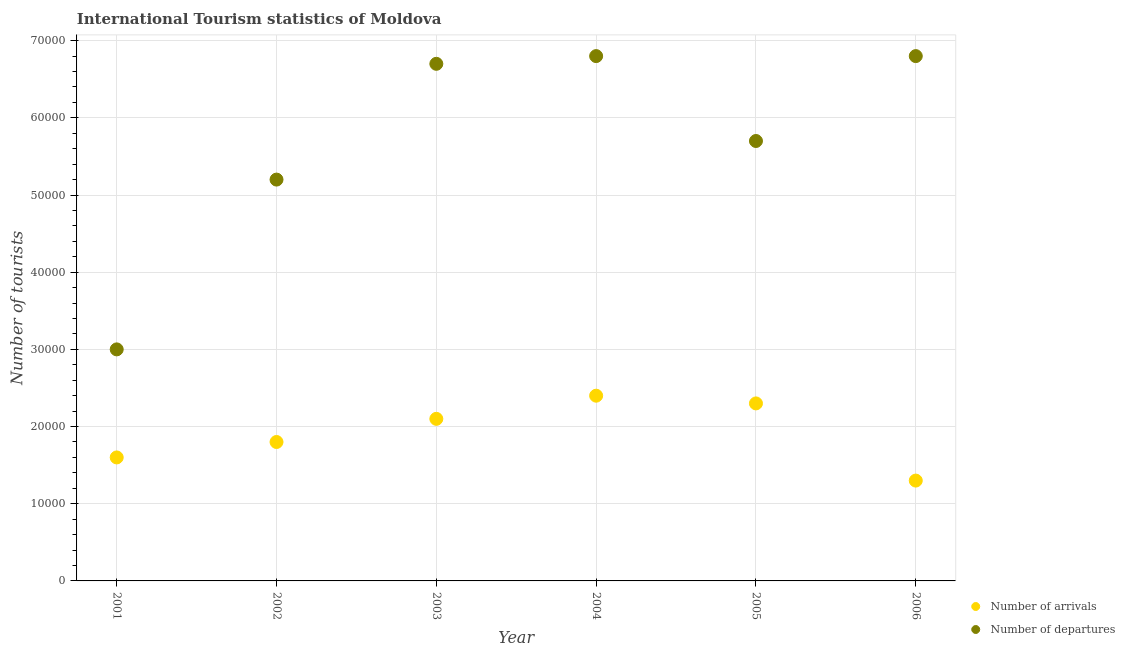What is the number of tourist departures in 2002?
Your answer should be very brief. 5.20e+04. Across all years, what is the maximum number of tourist arrivals?
Ensure brevity in your answer.  2.40e+04. Across all years, what is the minimum number of tourist departures?
Provide a short and direct response. 3.00e+04. In which year was the number of tourist departures maximum?
Provide a short and direct response. 2004. In which year was the number of tourist arrivals minimum?
Provide a short and direct response. 2006. What is the total number of tourist arrivals in the graph?
Keep it short and to the point. 1.15e+05. What is the difference between the number of tourist arrivals in 2001 and that in 2005?
Offer a very short reply. -7000. What is the difference between the number of tourist arrivals in 2002 and the number of tourist departures in 2005?
Provide a short and direct response. -3.90e+04. What is the average number of tourist departures per year?
Make the answer very short. 5.70e+04. In the year 2001, what is the difference between the number of tourist arrivals and number of tourist departures?
Your answer should be compact. -1.40e+04. What is the ratio of the number of tourist departures in 2003 to that in 2005?
Keep it short and to the point. 1.18. Is the number of tourist arrivals in 2001 less than that in 2004?
Keep it short and to the point. Yes. Is the difference between the number of tourist arrivals in 2001 and 2004 greater than the difference between the number of tourist departures in 2001 and 2004?
Make the answer very short. Yes. What is the difference between the highest and the lowest number of tourist departures?
Your answer should be very brief. 3.80e+04. In how many years, is the number of tourist departures greater than the average number of tourist departures taken over all years?
Your answer should be very brief. 3. Is the number of tourist departures strictly less than the number of tourist arrivals over the years?
Your answer should be very brief. No. How many years are there in the graph?
Provide a succinct answer. 6. Are the values on the major ticks of Y-axis written in scientific E-notation?
Make the answer very short. No. Does the graph contain grids?
Offer a very short reply. Yes. How are the legend labels stacked?
Keep it short and to the point. Vertical. What is the title of the graph?
Make the answer very short. International Tourism statistics of Moldova. Does "Male" appear as one of the legend labels in the graph?
Your answer should be compact. No. What is the label or title of the X-axis?
Keep it short and to the point. Year. What is the label or title of the Y-axis?
Your answer should be very brief. Number of tourists. What is the Number of tourists of Number of arrivals in 2001?
Make the answer very short. 1.60e+04. What is the Number of tourists of Number of arrivals in 2002?
Make the answer very short. 1.80e+04. What is the Number of tourists in Number of departures in 2002?
Your response must be concise. 5.20e+04. What is the Number of tourists of Number of arrivals in 2003?
Provide a succinct answer. 2.10e+04. What is the Number of tourists in Number of departures in 2003?
Provide a succinct answer. 6.70e+04. What is the Number of tourists in Number of arrivals in 2004?
Your answer should be compact. 2.40e+04. What is the Number of tourists of Number of departures in 2004?
Your response must be concise. 6.80e+04. What is the Number of tourists of Number of arrivals in 2005?
Your answer should be compact. 2.30e+04. What is the Number of tourists of Number of departures in 2005?
Your answer should be compact. 5.70e+04. What is the Number of tourists in Number of arrivals in 2006?
Provide a succinct answer. 1.30e+04. What is the Number of tourists in Number of departures in 2006?
Provide a succinct answer. 6.80e+04. Across all years, what is the maximum Number of tourists of Number of arrivals?
Your answer should be very brief. 2.40e+04. Across all years, what is the maximum Number of tourists of Number of departures?
Your response must be concise. 6.80e+04. Across all years, what is the minimum Number of tourists of Number of arrivals?
Give a very brief answer. 1.30e+04. Across all years, what is the minimum Number of tourists in Number of departures?
Your response must be concise. 3.00e+04. What is the total Number of tourists of Number of arrivals in the graph?
Keep it short and to the point. 1.15e+05. What is the total Number of tourists of Number of departures in the graph?
Offer a terse response. 3.42e+05. What is the difference between the Number of tourists in Number of arrivals in 2001 and that in 2002?
Give a very brief answer. -2000. What is the difference between the Number of tourists of Number of departures in 2001 and that in 2002?
Your answer should be compact. -2.20e+04. What is the difference between the Number of tourists in Number of arrivals in 2001 and that in 2003?
Your response must be concise. -5000. What is the difference between the Number of tourists in Number of departures in 2001 and that in 2003?
Offer a terse response. -3.70e+04. What is the difference between the Number of tourists of Number of arrivals in 2001 and that in 2004?
Your answer should be compact. -8000. What is the difference between the Number of tourists in Number of departures in 2001 and that in 2004?
Your answer should be compact. -3.80e+04. What is the difference between the Number of tourists of Number of arrivals in 2001 and that in 2005?
Offer a very short reply. -7000. What is the difference between the Number of tourists of Number of departures in 2001 and that in 2005?
Give a very brief answer. -2.70e+04. What is the difference between the Number of tourists in Number of arrivals in 2001 and that in 2006?
Keep it short and to the point. 3000. What is the difference between the Number of tourists of Number of departures in 2001 and that in 2006?
Your answer should be very brief. -3.80e+04. What is the difference between the Number of tourists of Number of arrivals in 2002 and that in 2003?
Your response must be concise. -3000. What is the difference between the Number of tourists of Number of departures in 2002 and that in 2003?
Your answer should be very brief. -1.50e+04. What is the difference between the Number of tourists of Number of arrivals in 2002 and that in 2004?
Ensure brevity in your answer.  -6000. What is the difference between the Number of tourists of Number of departures in 2002 and that in 2004?
Ensure brevity in your answer.  -1.60e+04. What is the difference between the Number of tourists of Number of arrivals in 2002 and that in 2005?
Offer a very short reply. -5000. What is the difference between the Number of tourists of Number of departures in 2002 and that in 2005?
Make the answer very short. -5000. What is the difference between the Number of tourists of Number of departures in 2002 and that in 2006?
Your answer should be compact. -1.60e+04. What is the difference between the Number of tourists in Number of arrivals in 2003 and that in 2004?
Offer a terse response. -3000. What is the difference between the Number of tourists of Number of departures in 2003 and that in 2004?
Ensure brevity in your answer.  -1000. What is the difference between the Number of tourists of Number of arrivals in 2003 and that in 2005?
Offer a terse response. -2000. What is the difference between the Number of tourists of Number of departures in 2003 and that in 2005?
Your response must be concise. 10000. What is the difference between the Number of tourists in Number of arrivals in 2003 and that in 2006?
Your response must be concise. 8000. What is the difference between the Number of tourists in Number of departures in 2003 and that in 2006?
Your answer should be very brief. -1000. What is the difference between the Number of tourists in Number of arrivals in 2004 and that in 2005?
Provide a short and direct response. 1000. What is the difference between the Number of tourists in Number of departures in 2004 and that in 2005?
Offer a very short reply. 1.10e+04. What is the difference between the Number of tourists in Number of arrivals in 2004 and that in 2006?
Your response must be concise. 1.10e+04. What is the difference between the Number of tourists in Number of departures in 2004 and that in 2006?
Give a very brief answer. 0. What is the difference between the Number of tourists of Number of departures in 2005 and that in 2006?
Offer a terse response. -1.10e+04. What is the difference between the Number of tourists in Number of arrivals in 2001 and the Number of tourists in Number of departures in 2002?
Your response must be concise. -3.60e+04. What is the difference between the Number of tourists of Number of arrivals in 2001 and the Number of tourists of Number of departures in 2003?
Your answer should be compact. -5.10e+04. What is the difference between the Number of tourists in Number of arrivals in 2001 and the Number of tourists in Number of departures in 2004?
Your answer should be compact. -5.20e+04. What is the difference between the Number of tourists in Number of arrivals in 2001 and the Number of tourists in Number of departures in 2005?
Your answer should be compact. -4.10e+04. What is the difference between the Number of tourists of Number of arrivals in 2001 and the Number of tourists of Number of departures in 2006?
Your answer should be compact. -5.20e+04. What is the difference between the Number of tourists of Number of arrivals in 2002 and the Number of tourists of Number of departures in 2003?
Provide a short and direct response. -4.90e+04. What is the difference between the Number of tourists in Number of arrivals in 2002 and the Number of tourists in Number of departures in 2004?
Your answer should be compact. -5.00e+04. What is the difference between the Number of tourists in Number of arrivals in 2002 and the Number of tourists in Number of departures in 2005?
Your answer should be very brief. -3.90e+04. What is the difference between the Number of tourists in Number of arrivals in 2003 and the Number of tourists in Number of departures in 2004?
Provide a short and direct response. -4.70e+04. What is the difference between the Number of tourists of Number of arrivals in 2003 and the Number of tourists of Number of departures in 2005?
Your response must be concise. -3.60e+04. What is the difference between the Number of tourists of Number of arrivals in 2003 and the Number of tourists of Number of departures in 2006?
Provide a short and direct response. -4.70e+04. What is the difference between the Number of tourists of Number of arrivals in 2004 and the Number of tourists of Number of departures in 2005?
Your answer should be compact. -3.30e+04. What is the difference between the Number of tourists in Number of arrivals in 2004 and the Number of tourists in Number of departures in 2006?
Ensure brevity in your answer.  -4.40e+04. What is the difference between the Number of tourists of Number of arrivals in 2005 and the Number of tourists of Number of departures in 2006?
Provide a succinct answer. -4.50e+04. What is the average Number of tourists of Number of arrivals per year?
Your response must be concise. 1.92e+04. What is the average Number of tourists of Number of departures per year?
Your response must be concise. 5.70e+04. In the year 2001, what is the difference between the Number of tourists of Number of arrivals and Number of tourists of Number of departures?
Provide a succinct answer. -1.40e+04. In the year 2002, what is the difference between the Number of tourists of Number of arrivals and Number of tourists of Number of departures?
Offer a very short reply. -3.40e+04. In the year 2003, what is the difference between the Number of tourists of Number of arrivals and Number of tourists of Number of departures?
Your answer should be compact. -4.60e+04. In the year 2004, what is the difference between the Number of tourists of Number of arrivals and Number of tourists of Number of departures?
Give a very brief answer. -4.40e+04. In the year 2005, what is the difference between the Number of tourists in Number of arrivals and Number of tourists in Number of departures?
Offer a very short reply. -3.40e+04. In the year 2006, what is the difference between the Number of tourists in Number of arrivals and Number of tourists in Number of departures?
Your answer should be very brief. -5.50e+04. What is the ratio of the Number of tourists of Number of departures in 2001 to that in 2002?
Keep it short and to the point. 0.58. What is the ratio of the Number of tourists in Number of arrivals in 2001 to that in 2003?
Provide a short and direct response. 0.76. What is the ratio of the Number of tourists in Number of departures in 2001 to that in 2003?
Your response must be concise. 0.45. What is the ratio of the Number of tourists in Number of departures in 2001 to that in 2004?
Provide a succinct answer. 0.44. What is the ratio of the Number of tourists in Number of arrivals in 2001 to that in 2005?
Ensure brevity in your answer.  0.7. What is the ratio of the Number of tourists of Number of departures in 2001 to that in 2005?
Make the answer very short. 0.53. What is the ratio of the Number of tourists in Number of arrivals in 2001 to that in 2006?
Provide a succinct answer. 1.23. What is the ratio of the Number of tourists in Number of departures in 2001 to that in 2006?
Your response must be concise. 0.44. What is the ratio of the Number of tourists of Number of departures in 2002 to that in 2003?
Give a very brief answer. 0.78. What is the ratio of the Number of tourists of Number of arrivals in 2002 to that in 2004?
Provide a succinct answer. 0.75. What is the ratio of the Number of tourists in Number of departures in 2002 to that in 2004?
Your answer should be very brief. 0.76. What is the ratio of the Number of tourists of Number of arrivals in 2002 to that in 2005?
Offer a terse response. 0.78. What is the ratio of the Number of tourists in Number of departures in 2002 to that in 2005?
Your answer should be compact. 0.91. What is the ratio of the Number of tourists of Number of arrivals in 2002 to that in 2006?
Your response must be concise. 1.38. What is the ratio of the Number of tourists in Number of departures in 2002 to that in 2006?
Make the answer very short. 0.76. What is the ratio of the Number of tourists in Number of arrivals in 2003 to that in 2004?
Provide a short and direct response. 0.88. What is the ratio of the Number of tourists of Number of departures in 2003 to that in 2004?
Keep it short and to the point. 0.99. What is the ratio of the Number of tourists in Number of departures in 2003 to that in 2005?
Keep it short and to the point. 1.18. What is the ratio of the Number of tourists of Number of arrivals in 2003 to that in 2006?
Offer a terse response. 1.62. What is the ratio of the Number of tourists in Number of arrivals in 2004 to that in 2005?
Your answer should be very brief. 1.04. What is the ratio of the Number of tourists of Number of departures in 2004 to that in 2005?
Provide a succinct answer. 1.19. What is the ratio of the Number of tourists in Number of arrivals in 2004 to that in 2006?
Provide a short and direct response. 1.85. What is the ratio of the Number of tourists of Number of arrivals in 2005 to that in 2006?
Give a very brief answer. 1.77. What is the ratio of the Number of tourists in Number of departures in 2005 to that in 2006?
Provide a succinct answer. 0.84. What is the difference between the highest and the second highest Number of tourists in Number of arrivals?
Give a very brief answer. 1000. What is the difference between the highest and the second highest Number of tourists of Number of departures?
Your answer should be very brief. 0. What is the difference between the highest and the lowest Number of tourists of Number of arrivals?
Your answer should be compact. 1.10e+04. What is the difference between the highest and the lowest Number of tourists in Number of departures?
Give a very brief answer. 3.80e+04. 